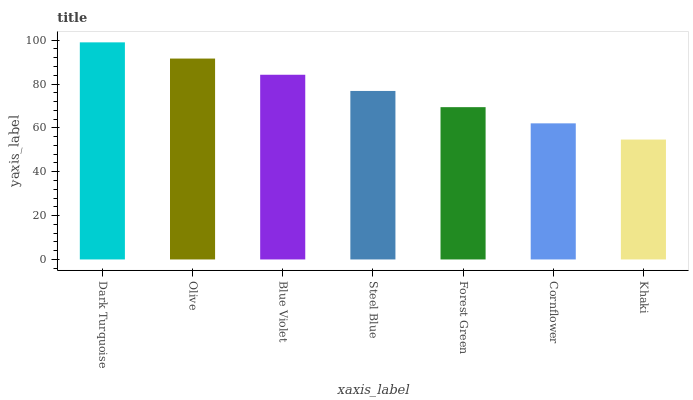Is Khaki the minimum?
Answer yes or no. Yes. Is Dark Turquoise the maximum?
Answer yes or no. Yes. Is Olive the minimum?
Answer yes or no. No. Is Olive the maximum?
Answer yes or no. No. Is Dark Turquoise greater than Olive?
Answer yes or no. Yes. Is Olive less than Dark Turquoise?
Answer yes or no. Yes. Is Olive greater than Dark Turquoise?
Answer yes or no. No. Is Dark Turquoise less than Olive?
Answer yes or no. No. Is Steel Blue the high median?
Answer yes or no. Yes. Is Steel Blue the low median?
Answer yes or no. Yes. Is Khaki the high median?
Answer yes or no. No. Is Dark Turquoise the low median?
Answer yes or no. No. 